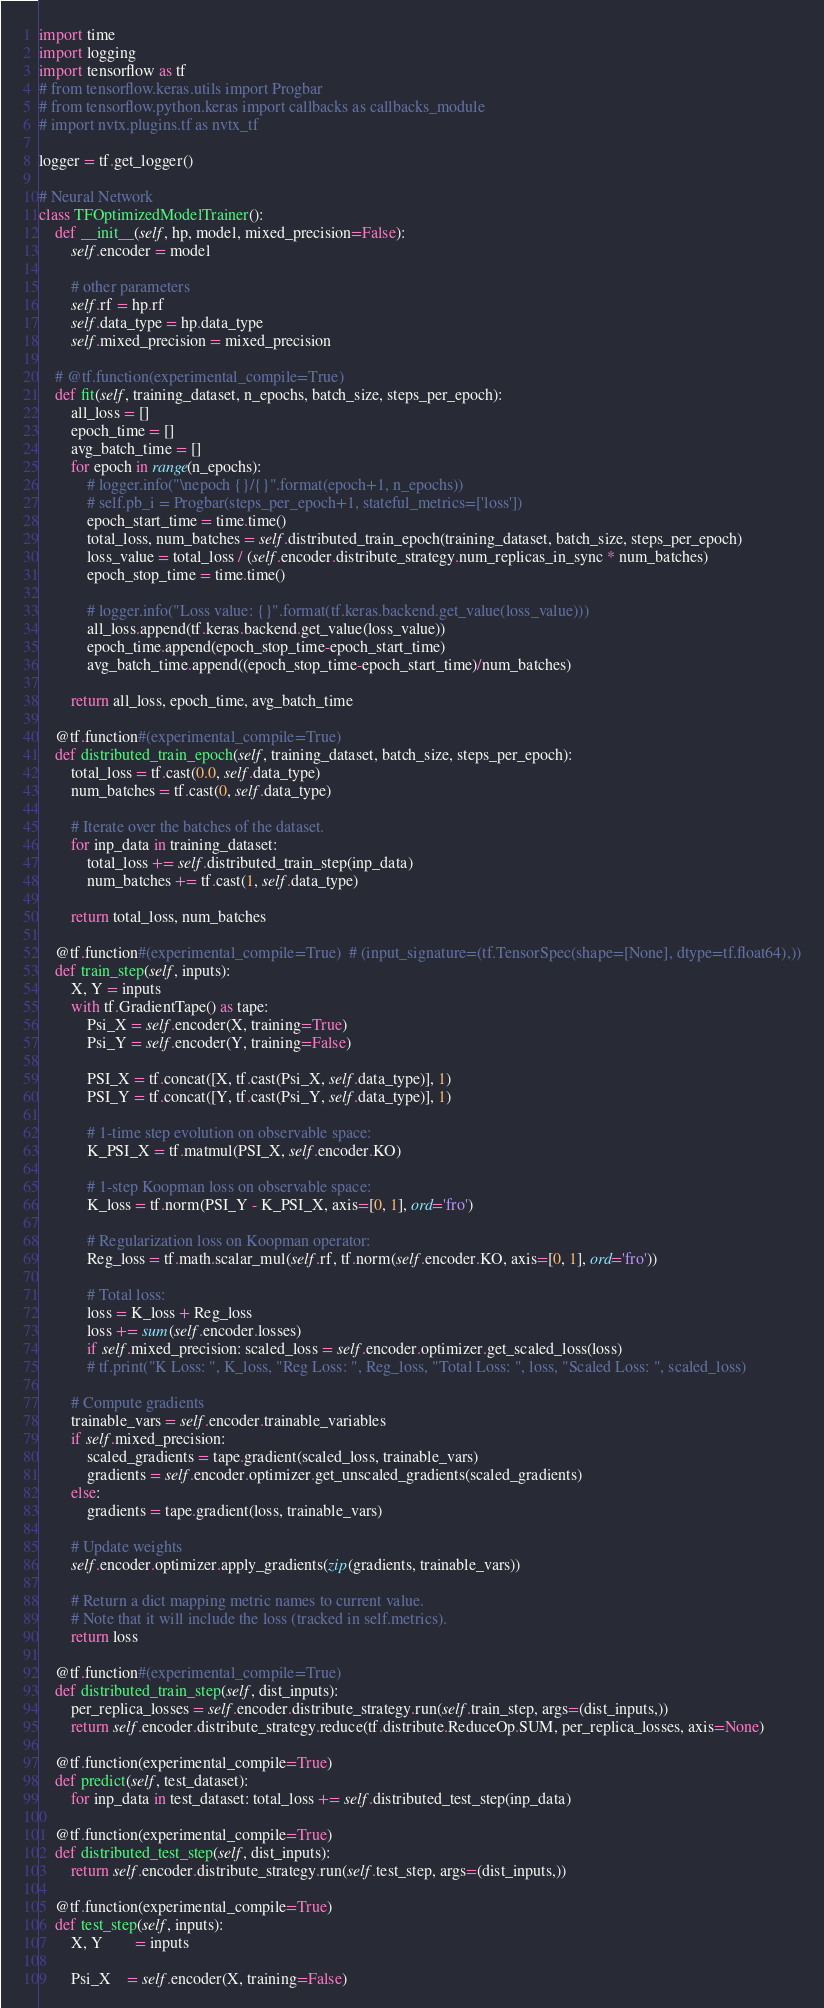<code> <loc_0><loc_0><loc_500><loc_500><_Python_>import time
import logging
import tensorflow as tf
# from tensorflow.keras.utils import Progbar
# from tensorflow.python.keras import callbacks as callbacks_module
# import nvtx.plugins.tf as nvtx_tf

logger = tf.get_logger()

# Neural Network
class TFOptimizedModelTrainer():
    def __init__(self, hp, model, mixed_precision=False):
        self.encoder = model

        # other parameters
        self.rf = hp.rf
        self.data_type = hp.data_type
        self.mixed_precision = mixed_precision

    # @tf.function(experimental_compile=True)
    def fit(self, training_dataset, n_epochs, batch_size, steps_per_epoch):
        all_loss = []
        epoch_time = []
        avg_batch_time = []
        for epoch in range(n_epochs):
            # logger.info("\nepoch {}/{}".format(epoch+1, n_epochs))
            # self.pb_i = Progbar(steps_per_epoch+1, stateful_metrics=['loss'])
            epoch_start_time = time.time()
            total_loss, num_batches = self.distributed_train_epoch(training_dataset, batch_size, steps_per_epoch)
            loss_value = total_loss / (self.encoder.distribute_strategy.num_replicas_in_sync * num_batches)
            epoch_stop_time = time.time()
            
            # logger.info("Loss value: {}".format(tf.keras.backend.get_value(loss_value)))
            all_loss.append(tf.keras.backend.get_value(loss_value))
            epoch_time.append(epoch_stop_time-epoch_start_time)
            avg_batch_time.append((epoch_stop_time-epoch_start_time)/num_batches)
            
        return all_loss, epoch_time, avg_batch_time

    @tf.function#(experimental_compile=True)
    def distributed_train_epoch(self, training_dataset, batch_size, steps_per_epoch):
        total_loss = tf.cast(0.0, self.data_type)
        num_batches = tf.cast(0, self.data_type)

        # Iterate over the batches of the dataset.
        for inp_data in training_dataset:
            total_loss += self.distributed_train_step(inp_data)
            num_batches += tf.cast(1, self.data_type)

        return total_loss, num_batches

    @tf.function#(experimental_compile=True)  # (input_signature=(tf.TensorSpec(shape=[None], dtype=tf.float64),))
    def train_step(self, inputs):
        X, Y = inputs
        with tf.GradientTape() as tape:
            Psi_X = self.encoder(X, training=True)
            Psi_Y = self.encoder(Y, training=False)

            PSI_X = tf.concat([X, tf.cast(Psi_X, self.data_type)], 1)
            PSI_Y = tf.concat([Y, tf.cast(Psi_Y, self.data_type)], 1)

            # 1-time step evolution on observable space:
            K_PSI_X = tf.matmul(PSI_X, self.encoder.KO)

            # 1-step Koopman loss on observable space:
            K_loss = tf.norm(PSI_Y - K_PSI_X, axis=[0, 1], ord='fro')

            # Regularization loss on Koopman operator:
            Reg_loss = tf.math.scalar_mul(self.rf, tf.norm(self.encoder.KO, axis=[0, 1], ord='fro'))

            # Total loss:
            loss = K_loss + Reg_loss
            loss += sum(self.encoder.losses)
            if self.mixed_precision: scaled_loss = self.encoder.optimizer.get_scaled_loss(loss)
            # tf.print("K Loss: ", K_loss, "Reg Loss: ", Reg_loss, "Total Loss: ", loss, "Scaled Loss: ", scaled_loss)

        # Compute gradients
        trainable_vars = self.encoder.trainable_variables
        if self.mixed_precision:
            scaled_gradients = tape.gradient(scaled_loss, trainable_vars)
            gradients = self.encoder.optimizer.get_unscaled_gradients(scaled_gradients)
        else:
            gradients = tape.gradient(loss, trainable_vars)

        # Update weights
        self.encoder.optimizer.apply_gradients(zip(gradients, trainable_vars))

        # Return a dict mapping metric names to current value.
        # Note that it will include the loss (tracked in self.metrics).
        return loss

    @tf.function#(experimental_compile=True)
    def distributed_train_step(self, dist_inputs):
        per_replica_losses = self.encoder.distribute_strategy.run(self.train_step, args=(dist_inputs,))
        return self.encoder.distribute_strategy.reduce(tf.distribute.ReduceOp.SUM, per_replica_losses, axis=None)

    @tf.function(experimental_compile=True)
    def predict(self, test_dataset):
        for inp_data in test_dataset: total_loss += self.distributed_test_step(inp_data)

    @tf.function(experimental_compile=True)
    def distributed_test_step(self, dist_inputs):
        return self.encoder.distribute_strategy.run(self.test_step, args=(dist_inputs,))

    @tf.function(experimental_compile=True)
    def test_step(self, inputs): 
        X, Y        = inputs

        Psi_X    = self.encoder(X, training=False)</code> 